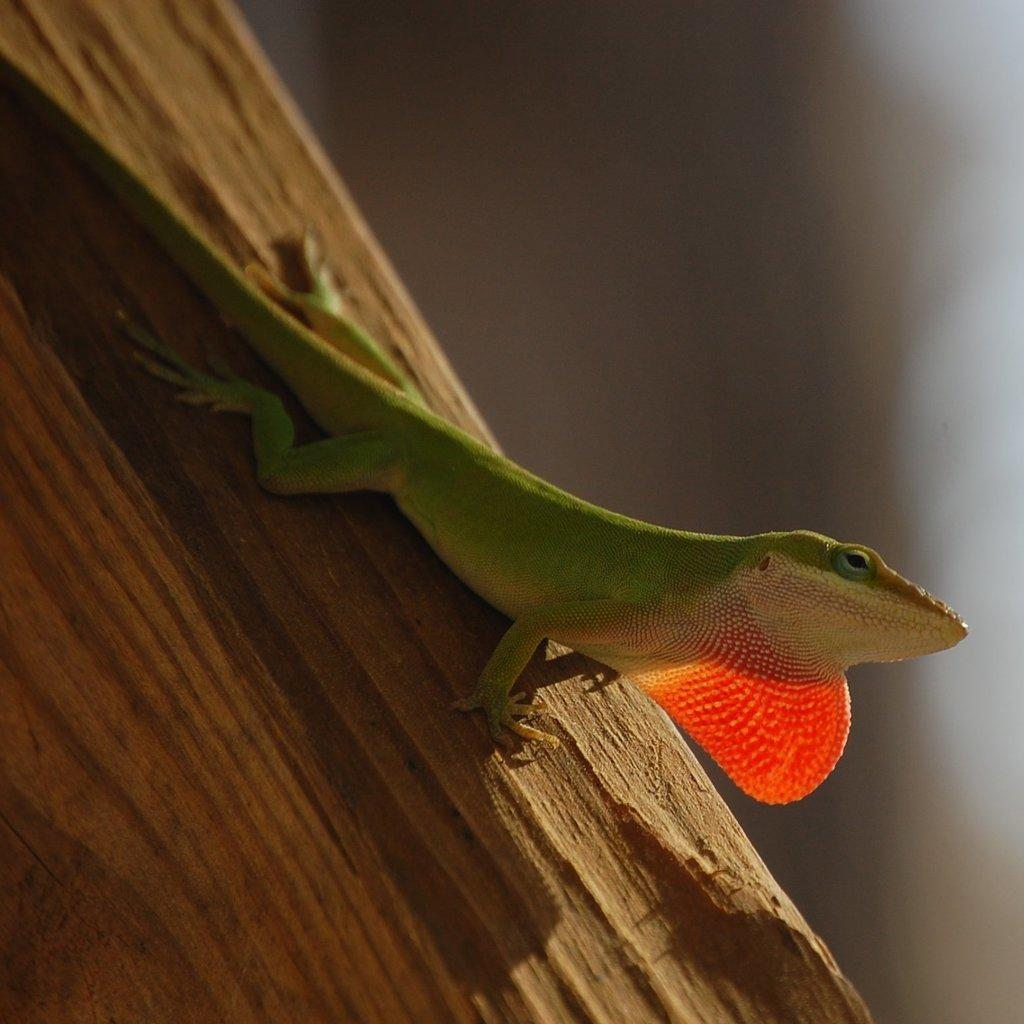What type of animal is in the picture? There is a reptile in the picture. What color is the reptile? The reptile is green in color. What surface is the reptile on? The reptile is on a wooden surface. What advice does the minister give to the reptile in the image? There is no minister present in the image, so no advice can be given. 